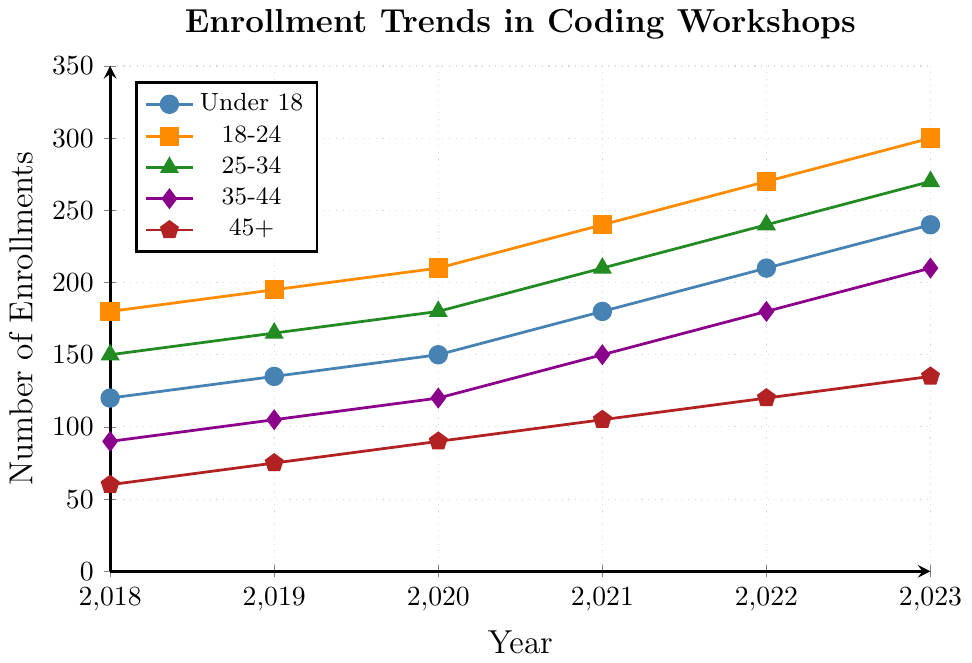What year saw the highest enrollment for the age group 18-24? Look at the plotted data points for the age group 18-24 and identify the highest point on the y-axis. Note the corresponding x-axis year.
Answer: 2023 Which age group had the smallest increase in enrollments from 2018 to 2023? Calculate the difference in enrollments between 2018 and 2023 for each age group: 
- Under 18: 240 - 120 = 120
- 18-24: 300 - 180 = 120
- 25-34: 270 - 150 = 120
- 35-44: 210 - 90 = 120
- 45+: 135 - 60 = 75
Answer: 45+ Which age group shows the most consistent increase in enrollments over the years? Check the plotted lines for each age group to see which line has the smallest fluctuations and a steady upward trend over the years.
Answer: 18-24 